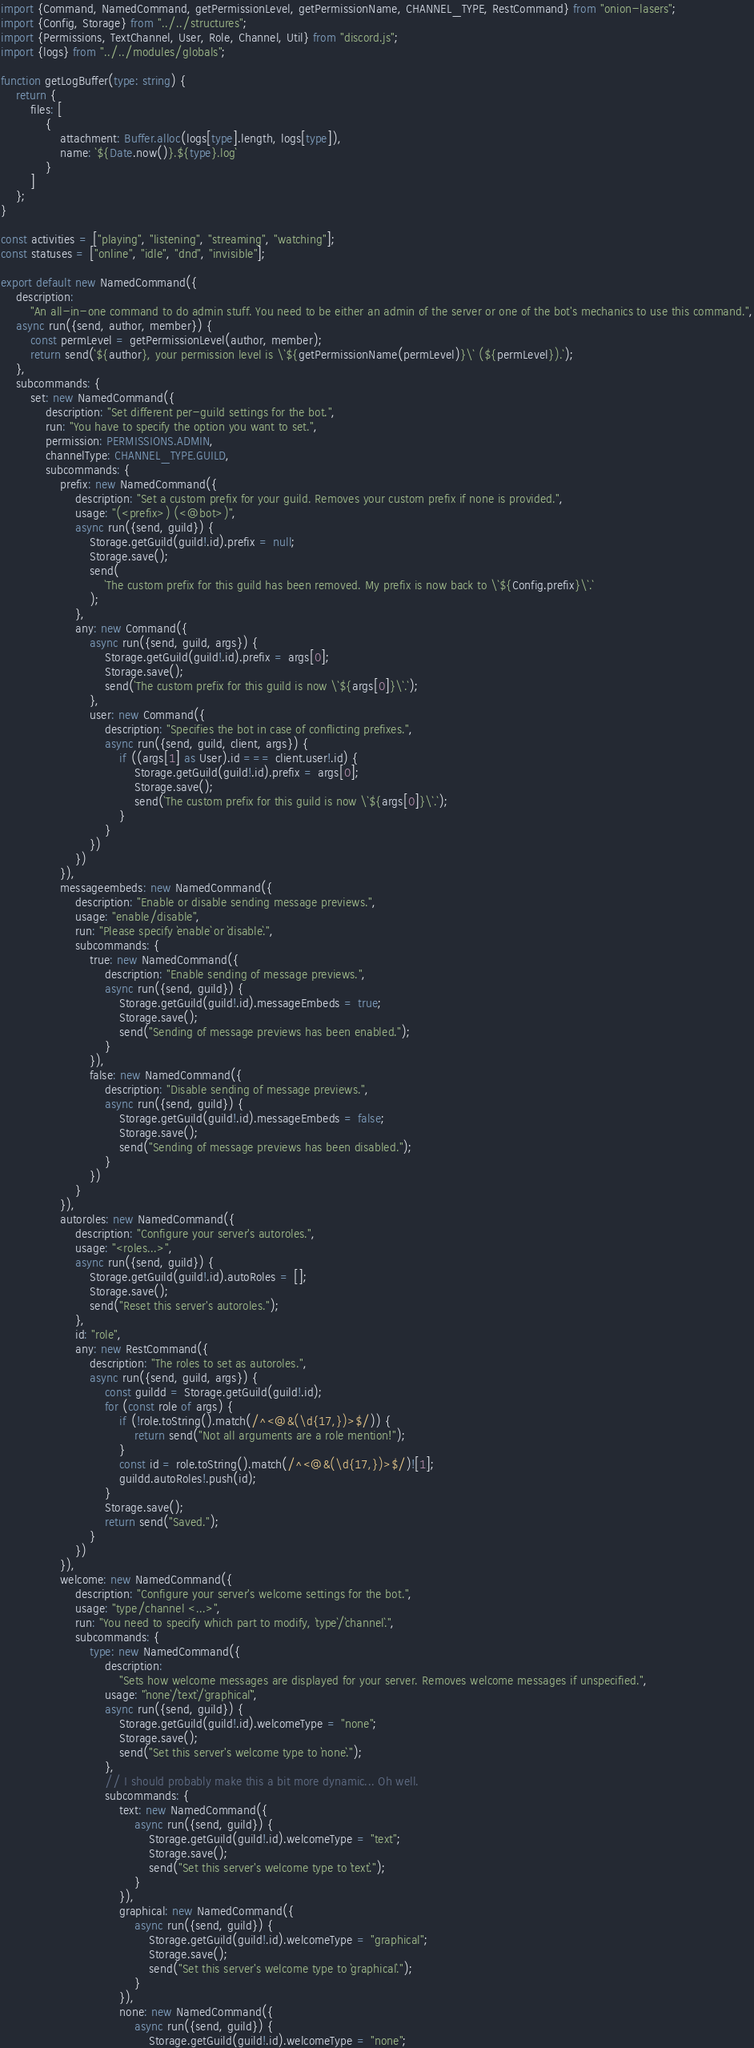<code> <loc_0><loc_0><loc_500><loc_500><_TypeScript_>import {Command, NamedCommand, getPermissionLevel, getPermissionName, CHANNEL_TYPE, RestCommand} from "onion-lasers";
import {Config, Storage} from "../../structures";
import {Permissions, TextChannel, User, Role, Channel, Util} from "discord.js";
import {logs} from "../../modules/globals";

function getLogBuffer(type: string) {
    return {
        files: [
            {
                attachment: Buffer.alloc(logs[type].length, logs[type]),
                name: `${Date.now()}.${type}.log`
            }
        ]
    };
}

const activities = ["playing", "listening", "streaming", "watching"];
const statuses = ["online", "idle", "dnd", "invisible"];

export default new NamedCommand({
    description:
        "An all-in-one command to do admin stuff. You need to be either an admin of the server or one of the bot's mechanics to use this command.",
    async run({send, author, member}) {
        const permLevel = getPermissionLevel(author, member);
        return send(`${author}, your permission level is \`${getPermissionName(permLevel)}\` (${permLevel}).`);
    },
    subcommands: {
        set: new NamedCommand({
            description: "Set different per-guild settings for the bot.",
            run: "You have to specify the option you want to set.",
            permission: PERMISSIONS.ADMIN,
            channelType: CHANNEL_TYPE.GUILD,
            subcommands: {
                prefix: new NamedCommand({
                    description: "Set a custom prefix for your guild. Removes your custom prefix if none is provided.",
                    usage: "(<prefix>) (<@bot>)",
                    async run({send, guild}) {
                        Storage.getGuild(guild!.id).prefix = null;
                        Storage.save();
                        send(
                            `The custom prefix for this guild has been removed. My prefix is now back to \`${Config.prefix}\`.`
                        );
                    },
                    any: new Command({
                        async run({send, guild, args}) {
                            Storage.getGuild(guild!.id).prefix = args[0];
                            Storage.save();
                            send(`The custom prefix for this guild is now \`${args[0]}\`.`);
                        },
                        user: new Command({
                            description: "Specifies the bot in case of conflicting prefixes.",
                            async run({send, guild, client, args}) {
                                if ((args[1] as User).id === client.user!.id) {
                                    Storage.getGuild(guild!.id).prefix = args[0];
                                    Storage.save();
                                    send(`The custom prefix for this guild is now \`${args[0]}\`.`);
                                }
                            }
                        })
                    })
                }),
                messageembeds: new NamedCommand({
                    description: "Enable or disable sending message previews.",
                    usage: "enable/disable",
                    run: "Please specify `enable` or `disable`.",
                    subcommands: {
                        true: new NamedCommand({
                            description: "Enable sending of message previews.",
                            async run({send, guild}) {
                                Storage.getGuild(guild!.id).messageEmbeds = true;
                                Storage.save();
                                send("Sending of message previews has been enabled.");
                            }
                        }),
                        false: new NamedCommand({
                            description: "Disable sending of message previews.",
                            async run({send, guild}) {
                                Storage.getGuild(guild!.id).messageEmbeds = false;
                                Storage.save();
                                send("Sending of message previews has been disabled.");
                            }
                        })
                    }
                }),
                autoroles: new NamedCommand({
                    description: "Configure your server's autoroles.",
                    usage: "<roles...>",
                    async run({send, guild}) {
                        Storage.getGuild(guild!.id).autoRoles = [];
                        Storage.save();
                        send("Reset this server's autoroles.");
                    },
                    id: "role",
                    any: new RestCommand({
                        description: "The roles to set as autoroles.",
                        async run({send, guild, args}) {
                            const guildd = Storage.getGuild(guild!.id);
                            for (const role of args) {
                                if (!role.toString().match(/^<@&(\d{17,})>$/)) {
                                    return send("Not all arguments are a role mention!");
                                }
                                const id = role.toString().match(/^<@&(\d{17,})>$/)![1];
                                guildd.autoRoles!.push(id);
                            }
                            Storage.save();
                            return send("Saved.");
                        }
                    })
                }),
                welcome: new NamedCommand({
                    description: "Configure your server's welcome settings for the bot.",
                    usage: "type/channel <...>",
                    run: "You need to specify which part to modify, `type`/`channel`.",
                    subcommands: {
                        type: new NamedCommand({
                            description:
                                "Sets how welcome messages are displayed for your server. Removes welcome messages if unspecified.",
                            usage: "`none`/`text`/`graphical`",
                            async run({send, guild}) {
                                Storage.getGuild(guild!.id).welcomeType = "none";
                                Storage.save();
                                send("Set this server's welcome type to `none`.");
                            },
                            // I should probably make this a bit more dynamic... Oh well.
                            subcommands: {
                                text: new NamedCommand({
                                    async run({send, guild}) {
                                        Storage.getGuild(guild!.id).welcomeType = "text";
                                        Storage.save();
                                        send("Set this server's welcome type to `text`.");
                                    }
                                }),
                                graphical: new NamedCommand({
                                    async run({send, guild}) {
                                        Storage.getGuild(guild!.id).welcomeType = "graphical";
                                        Storage.save();
                                        send("Set this server's welcome type to `graphical`.");
                                    }
                                }),
                                none: new NamedCommand({
                                    async run({send, guild}) {
                                        Storage.getGuild(guild!.id).welcomeType = "none";</code> 